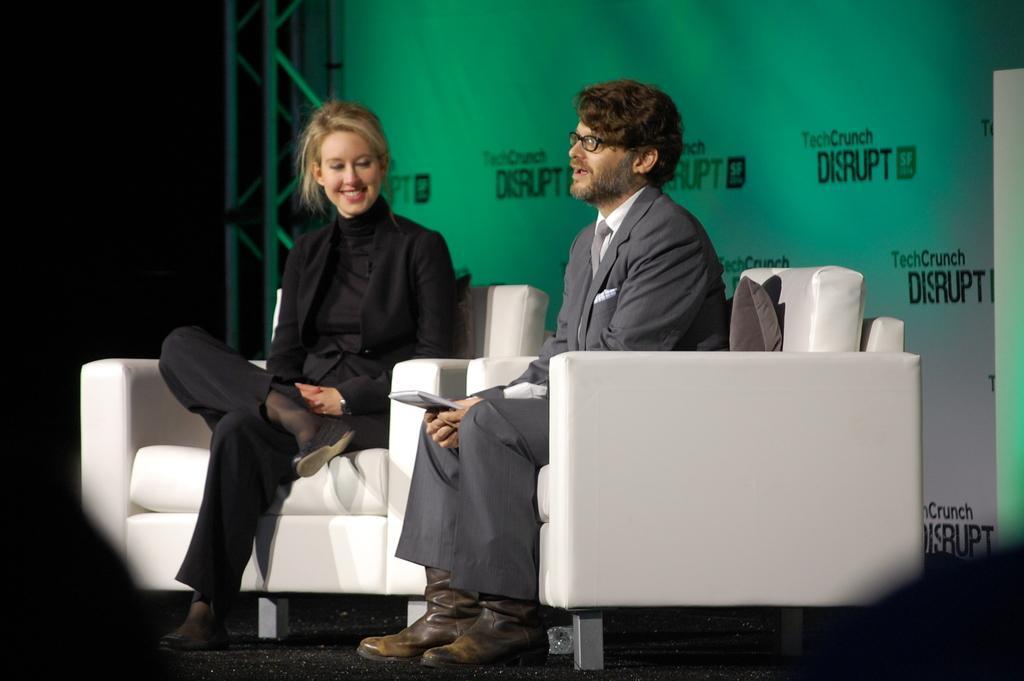Please provide a concise description of this image. In this picture I can see a man, woman sitting on the chairs, a man is holding book, behind we can see a banner. 